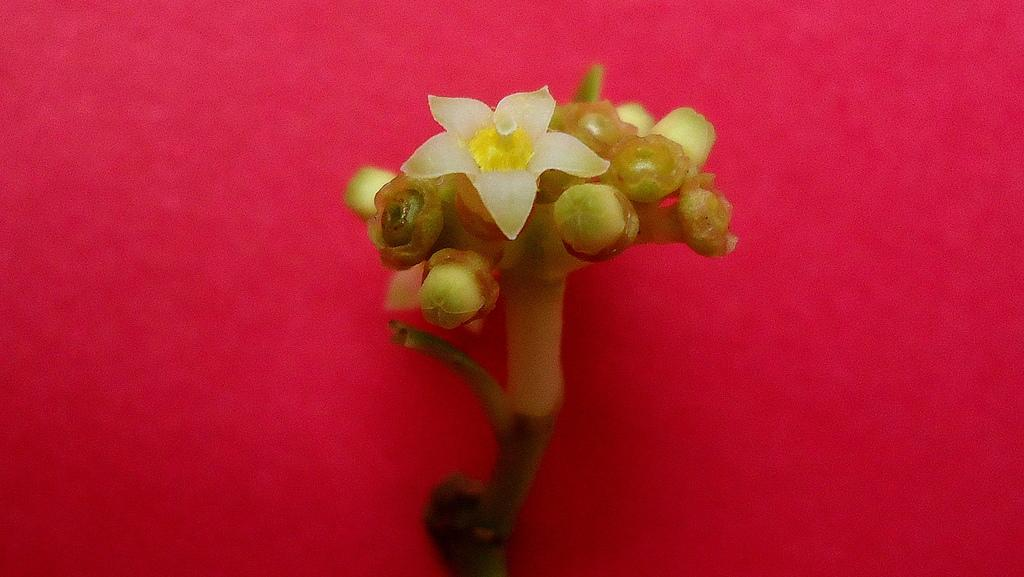What type of plant can be seen in the image? There is a flower in the image. Are there any unopened parts of the plant visible? Yes, there are buds in the image. Where are the flower and buds located? The flower and buds are placed on a table. What type of ear is visible in the image? There is no ear present in the image; it features a flower and buds on a table. Can you tell me how many corn kernels are on the flower in the image? There is no corn present in the image; it features a flower and buds on a table. 